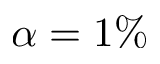<formula> <loc_0><loc_0><loc_500><loc_500>\alpha = 1 \%</formula> 